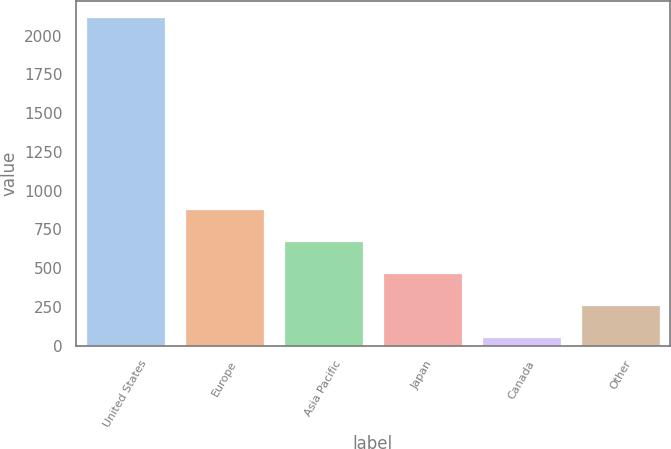Convert chart. <chart><loc_0><loc_0><loc_500><loc_500><bar_chart><fcel>United States<fcel>Europe<fcel>Asia Pacific<fcel>Japan<fcel>Canada<fcel>Other<nl><fcel>2116.8<fcel>880.98<fcel>675.01<fcel>469.04<fcel>57.1<fcel>263.07<nl></chart> 